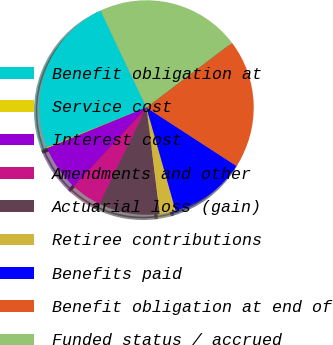<chart> <loc_0><loc_0><loc_500><loc_500><pie_chart><fcel>Benefit obligation at<fcel>Service cost<fcel>Interest cost<fcel>Amendments and other<fcel>Actuarial loss (gain)<fcel>Retiree contributions<fcel>Benefits paid<fcel>Benefit obligation at end of<fcel>Funded status / accrued<nl><fcel>24.0%<fcel>0.15%<fcel>6.93%<fcel>4.67%<fcel>9.19%<fcel>2.41%<fcel>11.45%<fcel>19.48%<fcel>21.74%<nl></chart> 